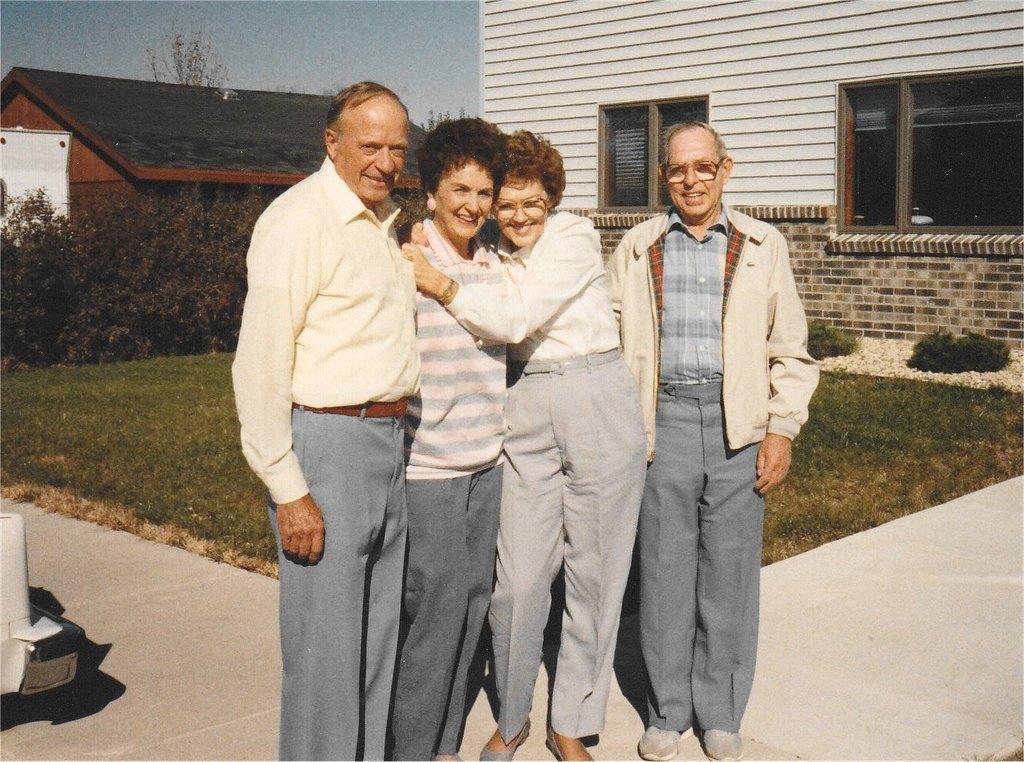How would you summarize this image in a sentence or two? In this image I can see group of people standing. In the background I can see few plants, buildings and the sky is in white and blue color. 